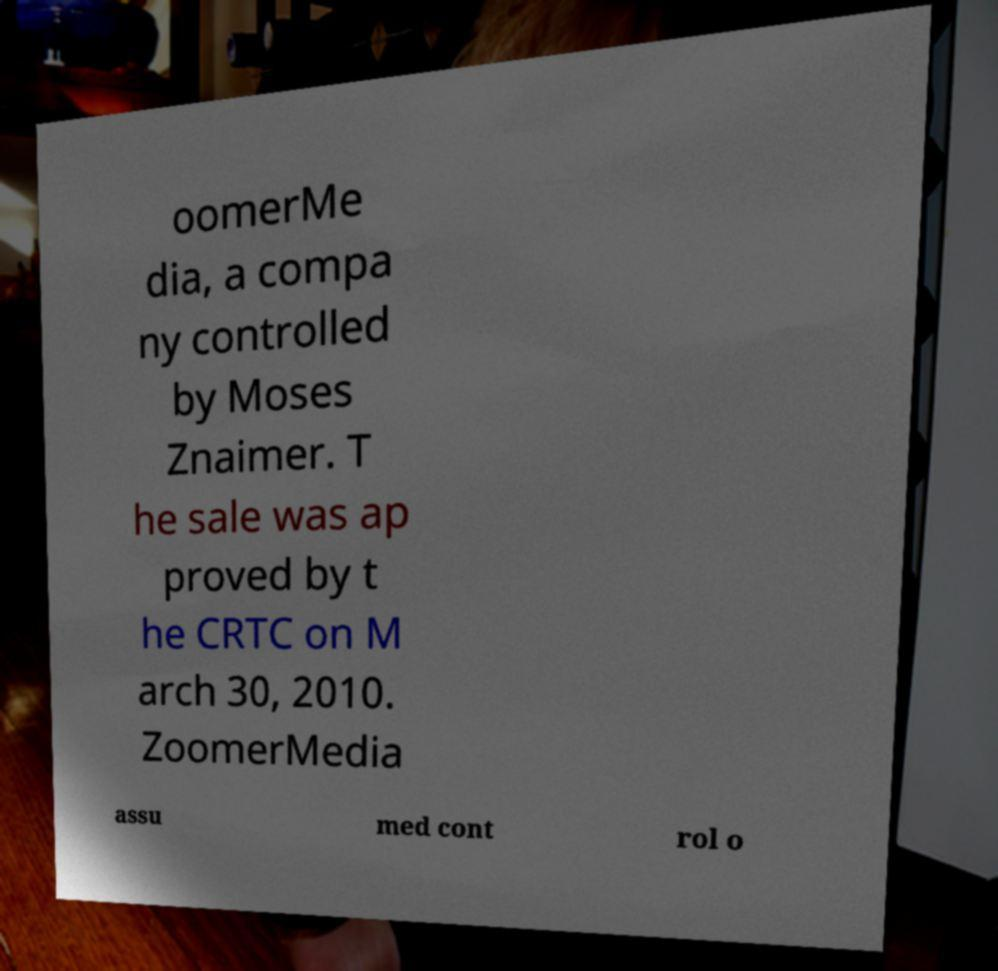I need the written content from this picture converted into text. Can you do that? oomerMe dia, a compa ny controlled by Moses Znaimer. T he sale was ap proved by t he CRTC on M arch 30, 2010. ZoomerMedia assu med cont rol o 